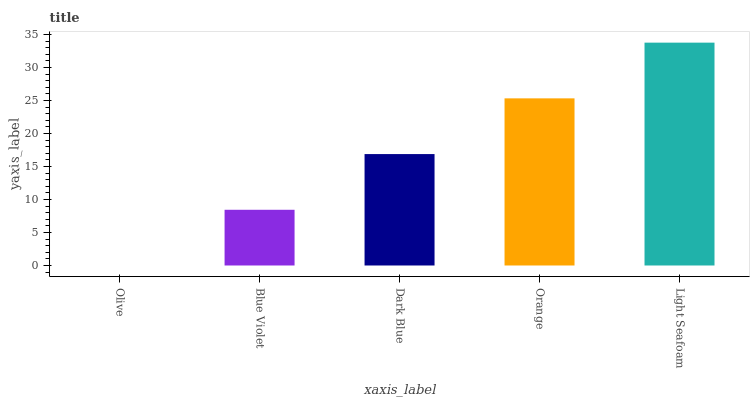Is Olive the minimum?
Answer yes or no. Yes. Is Light Seafoam the maximum?
Answer yes or no. Yes. Is Blue Violet the minimum?
Answer yes or no. No. Is Blue Violet the maximum?
Answer yes or no. No. Is Blue Violet greater than Olive?
Answer yes or no. Yes. Is Olive less than Blue Violet?
Answer yes or no. Yes. Is Olive greater than Blue Violet?
Answer yes or no. No. Is Blue Violet less than Olive?
Answer yes or no. No. Is Dark Blue the high median?
Answer yes or no. Yes. Is Dark Blue the low median?
Answer yes or no. Yes. Is Olive the high median?
Answer yes or no. No. Is Olive the low median?
Answer yes or no. No. 